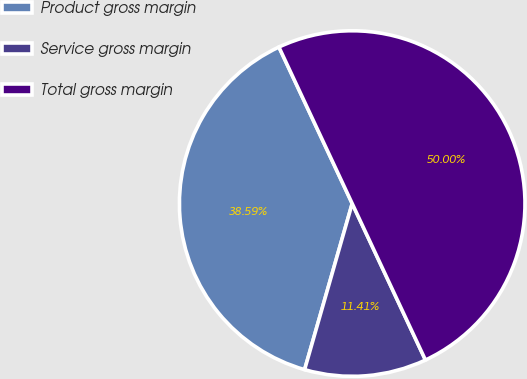<chart> <loc_0><loc_0><loc_500><loc_500><pie_chart><fcel>Product gross margin<fcel>Service gross margin<fcel>Total gross margin<nl><fcel>38.59%<fcel>11.41%<fcel>50.0%<nl></chart> 